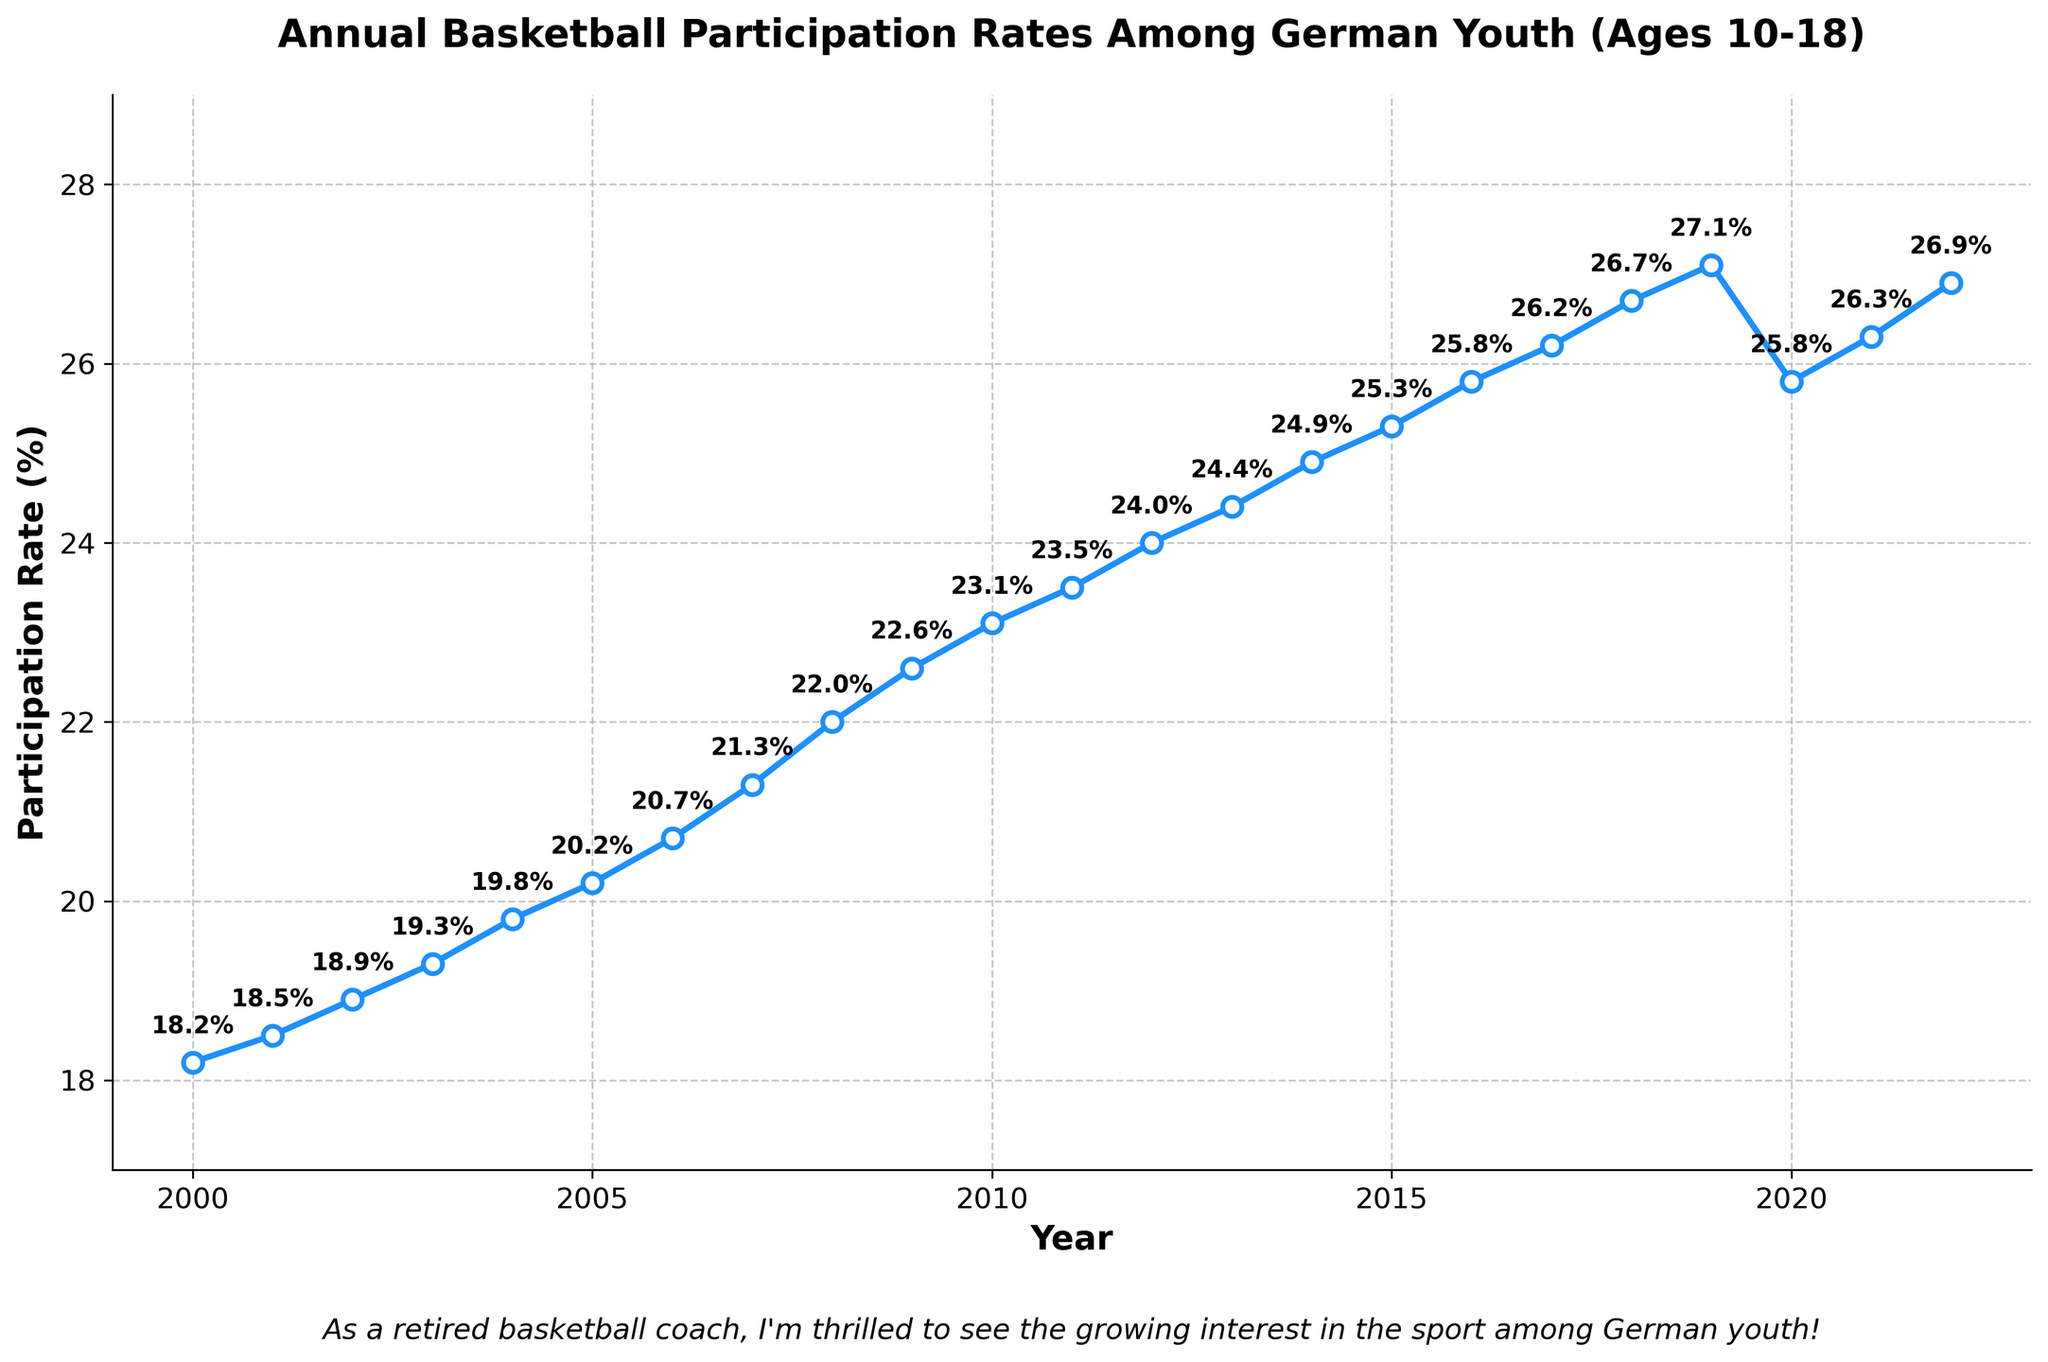How did the participation rate change from 2000 to 2022? The plot shows the participation rate in 2000 was 18.2%, and in 2022 it was 26.9%. The difference between 2022 and 2000 is 26.9% - 18.2% = 8.7%.
Answer: Increased by 8.7% Which year had the highest participation rate? The highest marker on the plot is in the year 2019, with a participation rate of 27.1%.
Answer: 2019 Was there ever a decrease in participation rates from one year to the next? If so, in which years? The only visible decrease is between 2019 and 2020, where the rate dropped from 27.1% to 25.8%.
Answer: 2019 to 2020 What is the average participation rate over the entire period? Summing the participation rates from 2000 to 2022 and dividing by the number of years (23), (18.2 + 18.5 + ... + 26.9) / 23, the average participation rate is approximately 22.86%.
Answer: 22.86% Between which consecutive years was the largest increase in participation rate observed? The plot shows the largest vertical jump between the years 2008 and 2009, from 22.0% to 22.6%. The increase is 22.6% - 22.0% = 0.6%.
Answer: 2008 to 2009 What was the participation rate in 2010 and how does it compare to the rate in 2020? In 2010, the rate was 23.1%. In 2020, it was 25.8%. Comparing them, 25.8% - 23.1% = 2.7%.
Answer: 2.7% higher in 2020 How does the participation rate in 2015 compare to the rate in 2005? In 2005, the rate was 20.2%. In 2015, it was 25.3%. The difference is 25.3% - 20.2% = 5.1%.
Answer: 5.1% higher in 2015 What is the participation rate's trend from 2000 to 2019? Visually, the line in the plot from 2000 to 2019 mostly goes upwards, indicating an increasing trend. The participation rates steady rise from 18.2% in 2000 to 27.1% in 2019.
Answer: Increasing What was the percentage drop in participation rate from 2019 to 2020? From 2019's 27.1% to 2020's 25.8%, the drop is 27.1% - 25.8% = 1.3%.
Answer: 1.3% How did the participation rate change from 2011 to 2015? From 2011’s 23.5% to 2015’s 25.3%, the rate increased by 25.3% - 23.5% = 1.8%.
Answer: Increased by 1.8% 